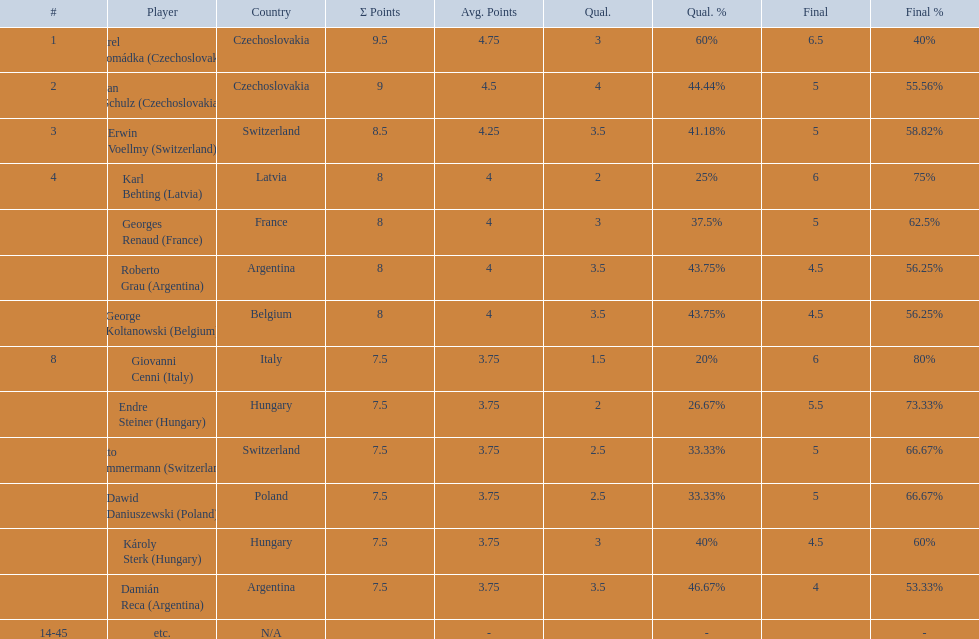Who was the top scorer from switzerland? Erwin Voellmy. 